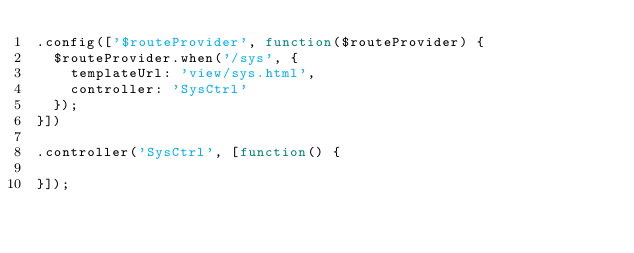Convert code to text. <code><loc_0><loc_0><loc_500><loc_500><_JavaScript_>.config(['$routeProvider', function($routeProvider) {
  $routeProvider.when('/sys', {
    templateUrl: 'view/sys.html',
    controller: 'SysCtrl'
  });
}])

.controller('SysCtrl', [function() {

}]);</code> 